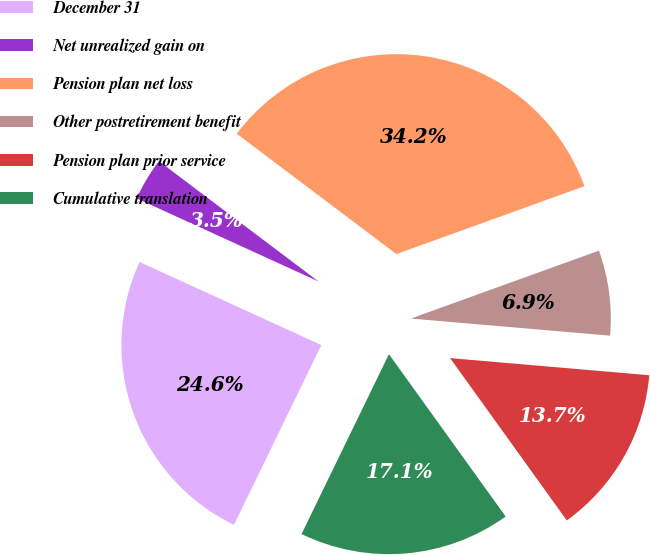<chart> <loc_0><loc_0><loc_500><loc_500><pie_chart><fcel>December 31<fcel>Net unrealized gain on<fcel>Pension plan net loss<fcel>Other postretirement benefit<fcel>Pension plan prior service<fcel>Cumulative translation<nl><fcel>24.62%<fcel>3.46%<fcel>34.2%<fcel>6.88%<fcel>13.71%<fcel>17.12%<nl></chart> 